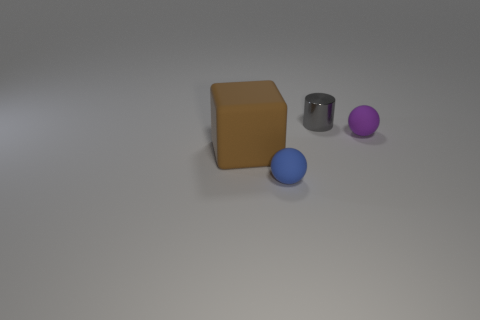What number of small matte things have the same color as the metal cylinder?
Offer a very short reply. 0. There is a object on the right side of the metallic cylinder; is it the same shape as the small thing that is to the left of the gray cylinder?
Provide a short and direct response. Yes. What color is the ball that is left of the rubber sphere that is to the right of the small rubber object that is in front of the purple object?
Keep it short and to the point. Blue. What is the color of the rubber thing that is in front of the large object?
Provide a succinct answer. Blue. There is another metal thing that is the same size as the blue object; what is its color?
Your answer should be very brief. Gray. Does the blue thing have the same size as the brown matte cube?
Offer a terse response. No. How many things are in front of the small gray shiny thing?
Offer a terse response. 3. What number of objects are tiny matte spheres right of the tiny metal thing or small rubber things?
Make the answer very short. 2. Is the number of things that are on the left side of the cylinder greater than the number of blocks that are in front of the large brown rubber cube?
Offer a terse response. Yes. There is a blue rubber ball; is it the same size as the object that is left of the small blue rubber object?
Your response must be concise. No. 